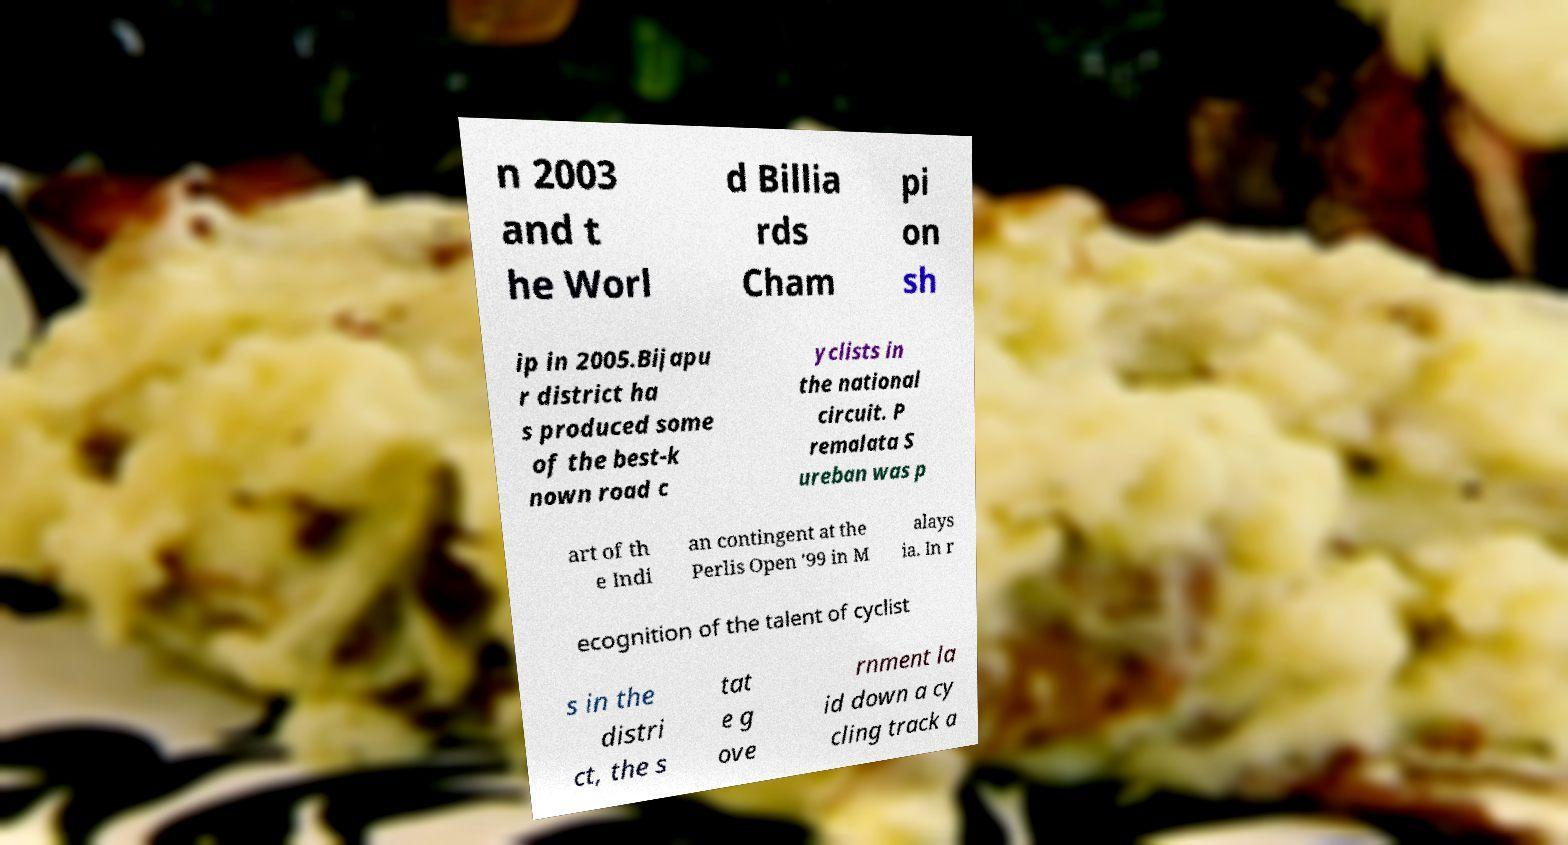Could you assist in decoding the text presented in this image and type it out clearly? n 2003 and t he Worl d Billia rds Cham pi on sh ip in 2005.Bijapu r district ha s produced some of the best-k nown road c yclists in the national circuit. P remalata S ureban was p art of th e Indi an contingent at the Perlis Open '99 in M alays ia. In r ecognition of the talent of cyclist s in the distri ct, the s tat e g ove rnment la id down a cy cling track a 